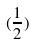<formula> <loc_0><loc_0><loc_500><loc_500>( \frac { 1 } { 2 } )</formula> 